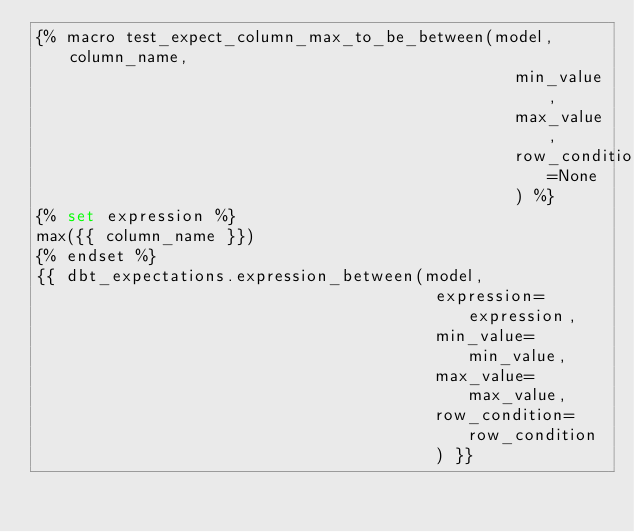Convert code to text. <code><loc_0><loc_0><loc_500><loc_500><_SQL_>{% macro test_expect_column_max_to_be_between(model, column_name,
                                                min_value,
                                                max_value,
                                                row_condition=None
                                                ) %}
{% set expression %}
max({{ column_name }})
{% endset %}
{{ dbt_expectations.expression_between(model,
                                        expression=expression,
                                        min_value=min_value,
                                        max_value=max_value,
                                        row_condition=row_condition
                                        ) }}</code> 